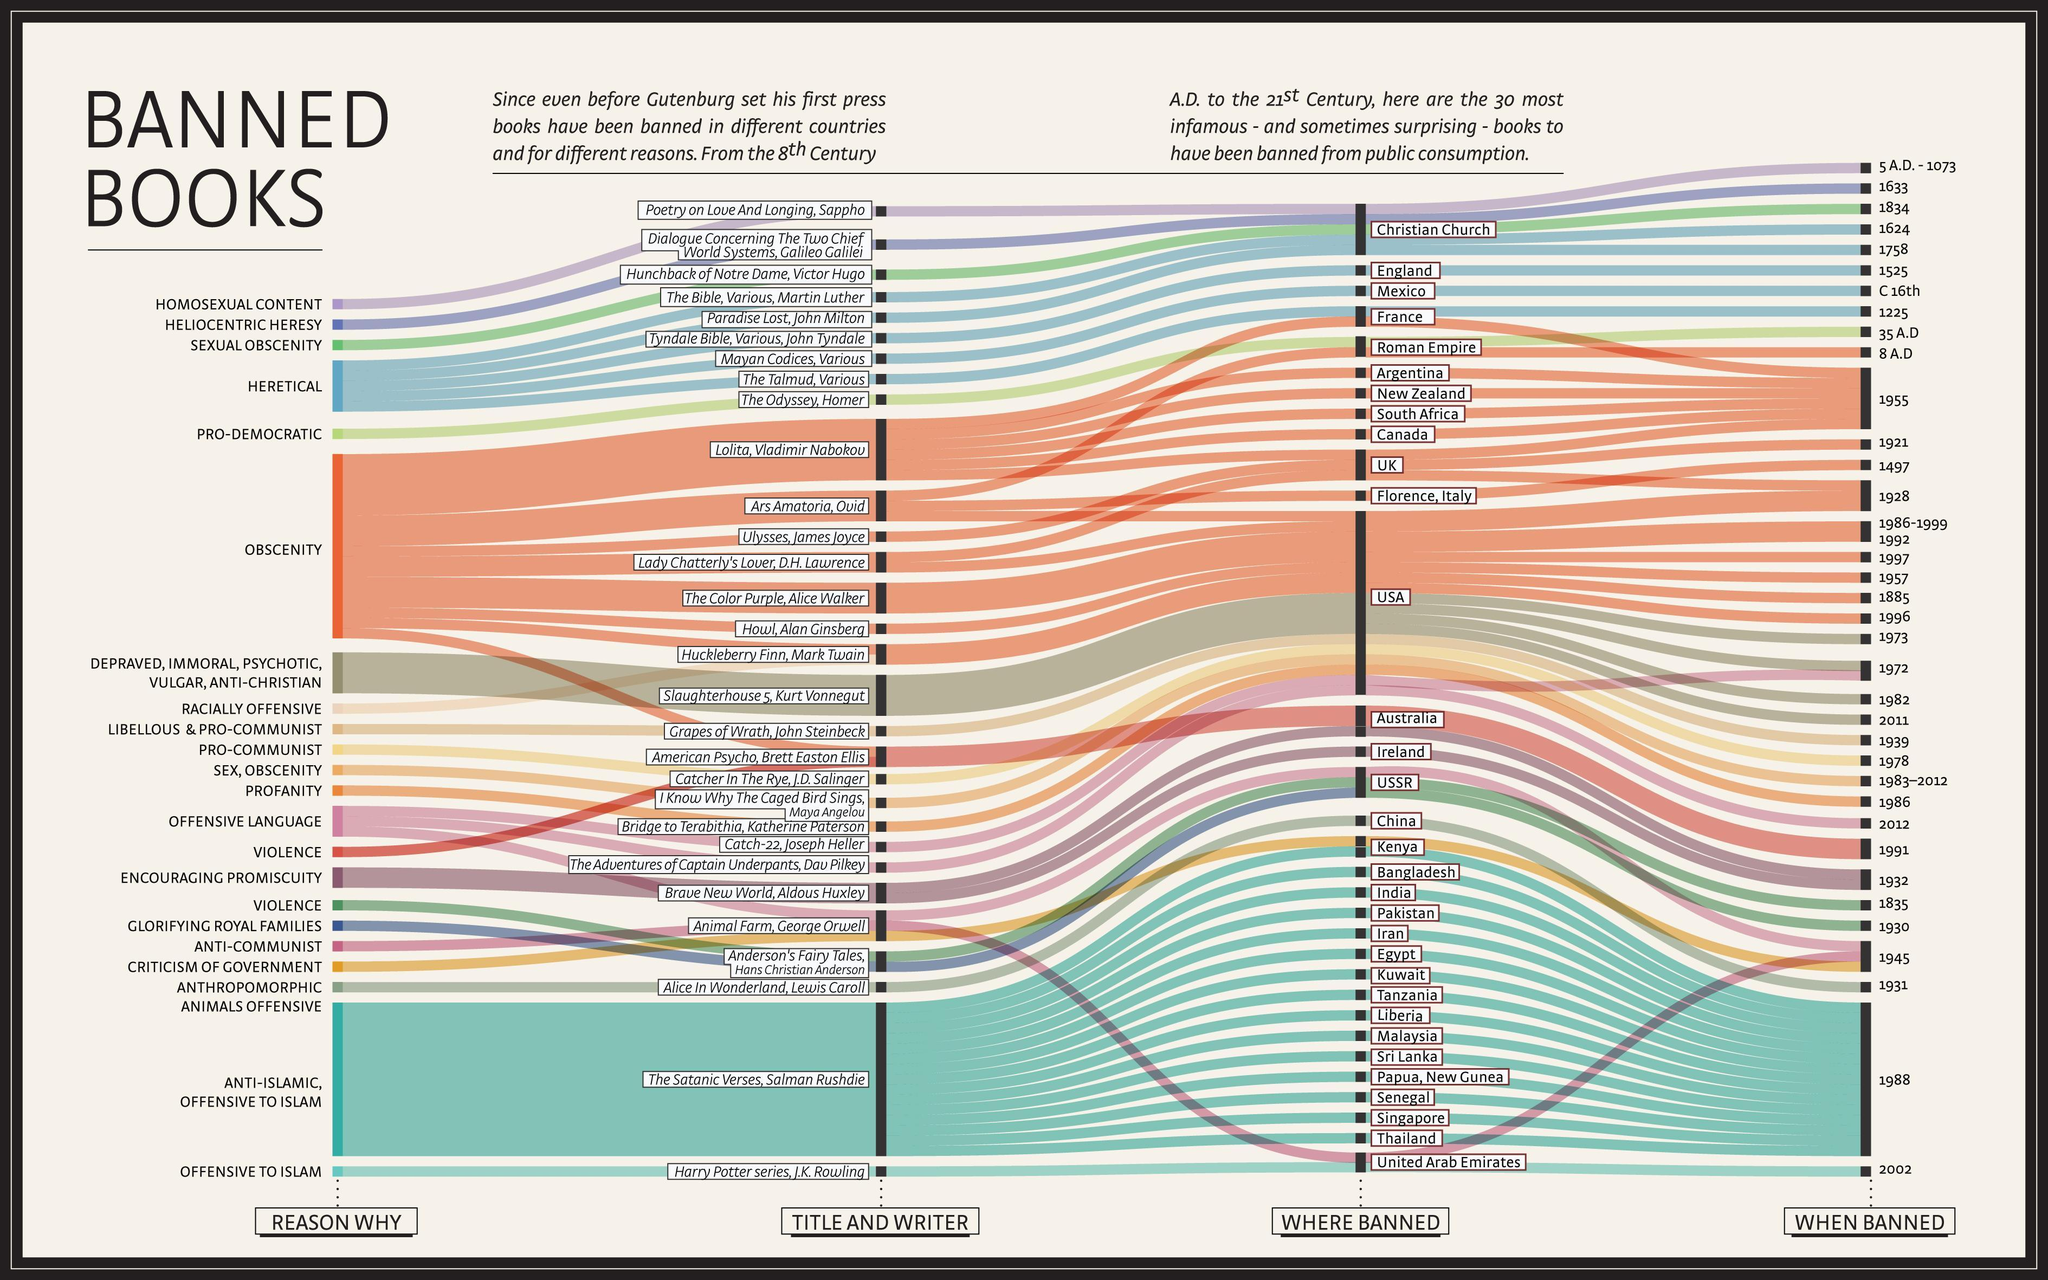How many books banned because of a violent nature?
Answer the question with a short phrase. 2 